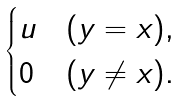Convert formula to latex. <formula><loc_0><loc_0><loc_500><loc_500>\begin{cases} u & ( y = x ) , \\ 0 & ( y \neq x ) . \end{cases}</formula> 